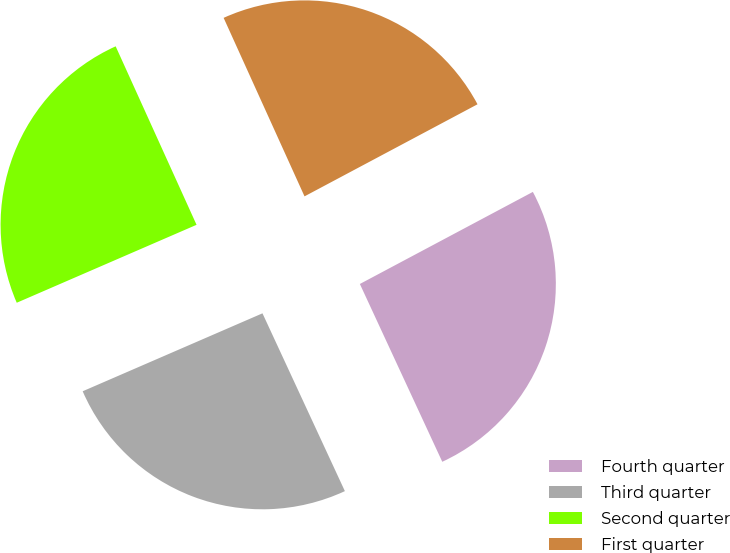Convert chart to OTSL. <chart><loc_0><loc_0><loc_500><loc_500><pie_chart><fcel>Fourth quarter<fcel>Third quarter<fcel>Second quarter<fcel>First quarter<nl><fcel>25.88%<fcel>25.4%<fcel>24.74%<fcel>23.99%<nl></chart> 